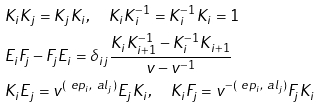Convert formula to latex. <formula><loc_0><loc_0><loc_500><loc_500>& K _ { i } K _ { j } = K _ { j } K _ { i } , \quad K _ { i } K _ { i } ^ { - 1 } = K _ { i } ^ { - 1 } K _ { i } = 1 \\ & E _ { i } F _ { j } - F _ { j } E _ { i } = \delta _ { i j } \frac { K _ { i } K _ { i + 1 } ^ { - 1 } - K _ { i } ^ { - 1 } K _ { i + 1 } } { v - v ^ { - 1 } } \\ & K _ { i } E _ { j } = v ^ { ( \ e p _ { i } , \ a l _ { j } ) } E _ { j } K _ { i } , \quad K _ { i } F _ { j } = v ^ { - ( \ e p _ { i } , \ a l _ { j } ) } F _ { j } K _ { i }</formula> 